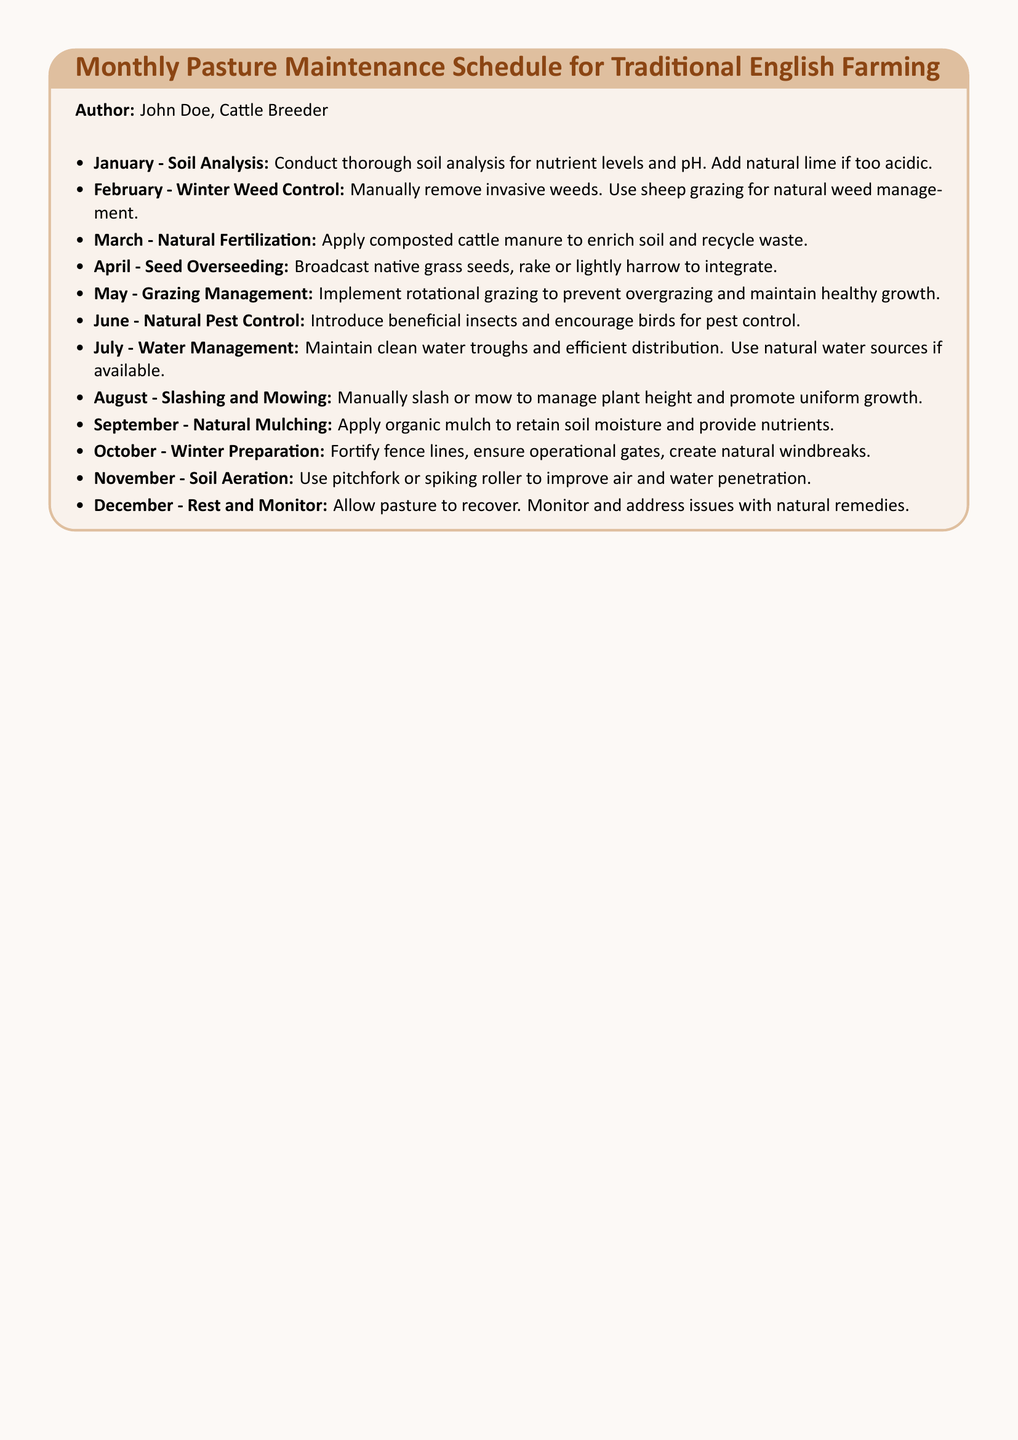What is the title of the document? The title of the document is stated at the beginning within the tcolorbox and describes the content focus.
Answer: Monthly Pasture Maintenance Schedule for Traditional English Farming Who is the author of the document? The author's name is listed right below the title in the document.
Answer: John Doe What month is dedicated to natural fertilization? The month for natural fertilization is specified in the schedule with the action to be taken.
Answer: March What natural method is suggested for controlling weeds in February? The document specifies a natural method for weed control that involves livestock.
Answer: Sheep grazing How is pest control managed in June? The document explains the methods suggested for pest control in June, which involves using natural allies.
Answer: Beneficial insects In which month should soil analysis be conducted? The schedule indicates that soil analysis should be performed in the first month of the year.
Answer: January What type of seeds is to be overseeded in April? The document refers to the seeds to be used for overseeding, indicating they are native.
Answer: Native grass seeds What is suggested for water management in July? The document outlines the steps necessary for maintaining water resources effectively.
Answer: Clean water troughs What action is recommended for December? The schedule provides an overall recommendation for the last month regarding pasture management.
Answer: Rest and Monitor 